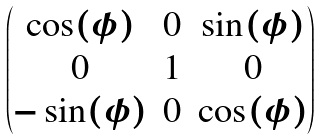<formula> <loc_0><loc_0><loc_500><loc_500>\begin{pmatrix} \cos ( \phi ) & 0 & \sin ( \phi ) \\ 0 & 1 & 0 \\ - \sin ( \phi ) & 0 & \cos ( \phi ) \end{pmatrix}</formula> 